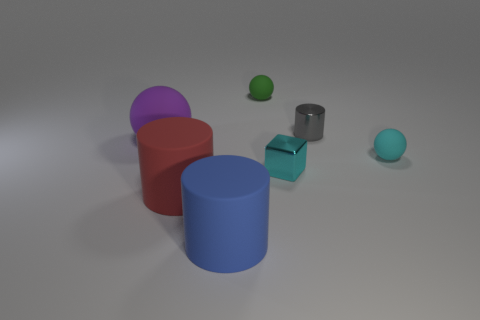Add 3 red cubes. How many objects exist? 10 Subtract all cylinders. How many objects are left? 4 Add 2 big red cylinders. How many big red cylinders exist? 3 Subtract 1 cyan blocks. How many objects are left? 6 Subtract all small red rubber balls. Subtract all metal cylinders. How many objects are left? 6 Add 1 cyan blocks. How many cyan blocks are left? 2 